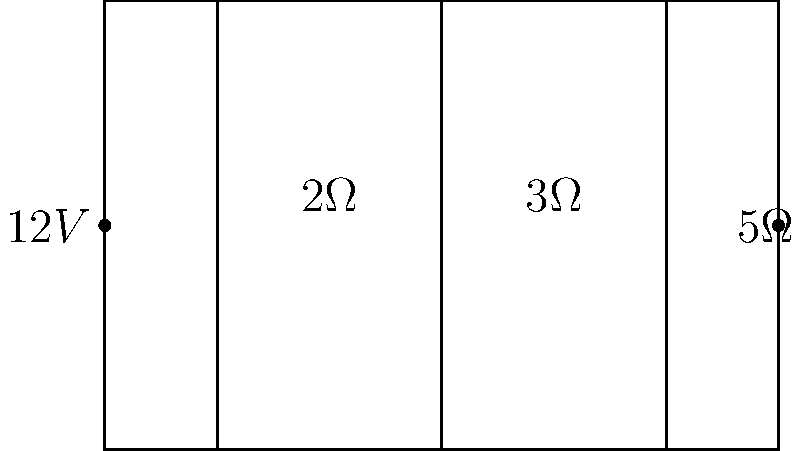In the circuit shown, a 12V battery is connected in series with three resistors: 2Ω, 3Ω, and 5Ω. What is the voltage drop across the 3Ω resistor? To solve this problem, we'll use Ohm's Law and voltage division principles. Let's break it down step-by-step:

1. Calculate the total resistance in the circuit:
   $R_{total} = 2\Omega + 3\Omega + 5\Omega = 10\Omega$

2. Calculate the current flowing through the circuit using Ohm's Law:
   $I = \frac{V}{R_{total}} = \frac{12V}{10\Omega} = 1.2A$

3. The voltage drop across each resistor is proportional to its resistance. We can use the voltage division formula:
   $V_{3\Omega} = \frac{3\Omega}{10\Omega} \times 12V = 3.6V$

This result shows that the 3Ω resistor, which represents 30% of the total resistance, will have 30% of the total voltage drop across it.

4. We can verify this by calculating the voltage drops across all resistors:
   $V_{2\Omega} = 2\Omega \times 1.2A = 2.4V$
   $V_{3\Omega} = 3\Omega \times 1.2A = 3.6V$
   $V_{5\Omega} = 5\Omega \times 1.2A = 6V$

   $2.4V + 3.6V + 6V = 12V$, which confirms our calculation.
Answer: 3.6V 